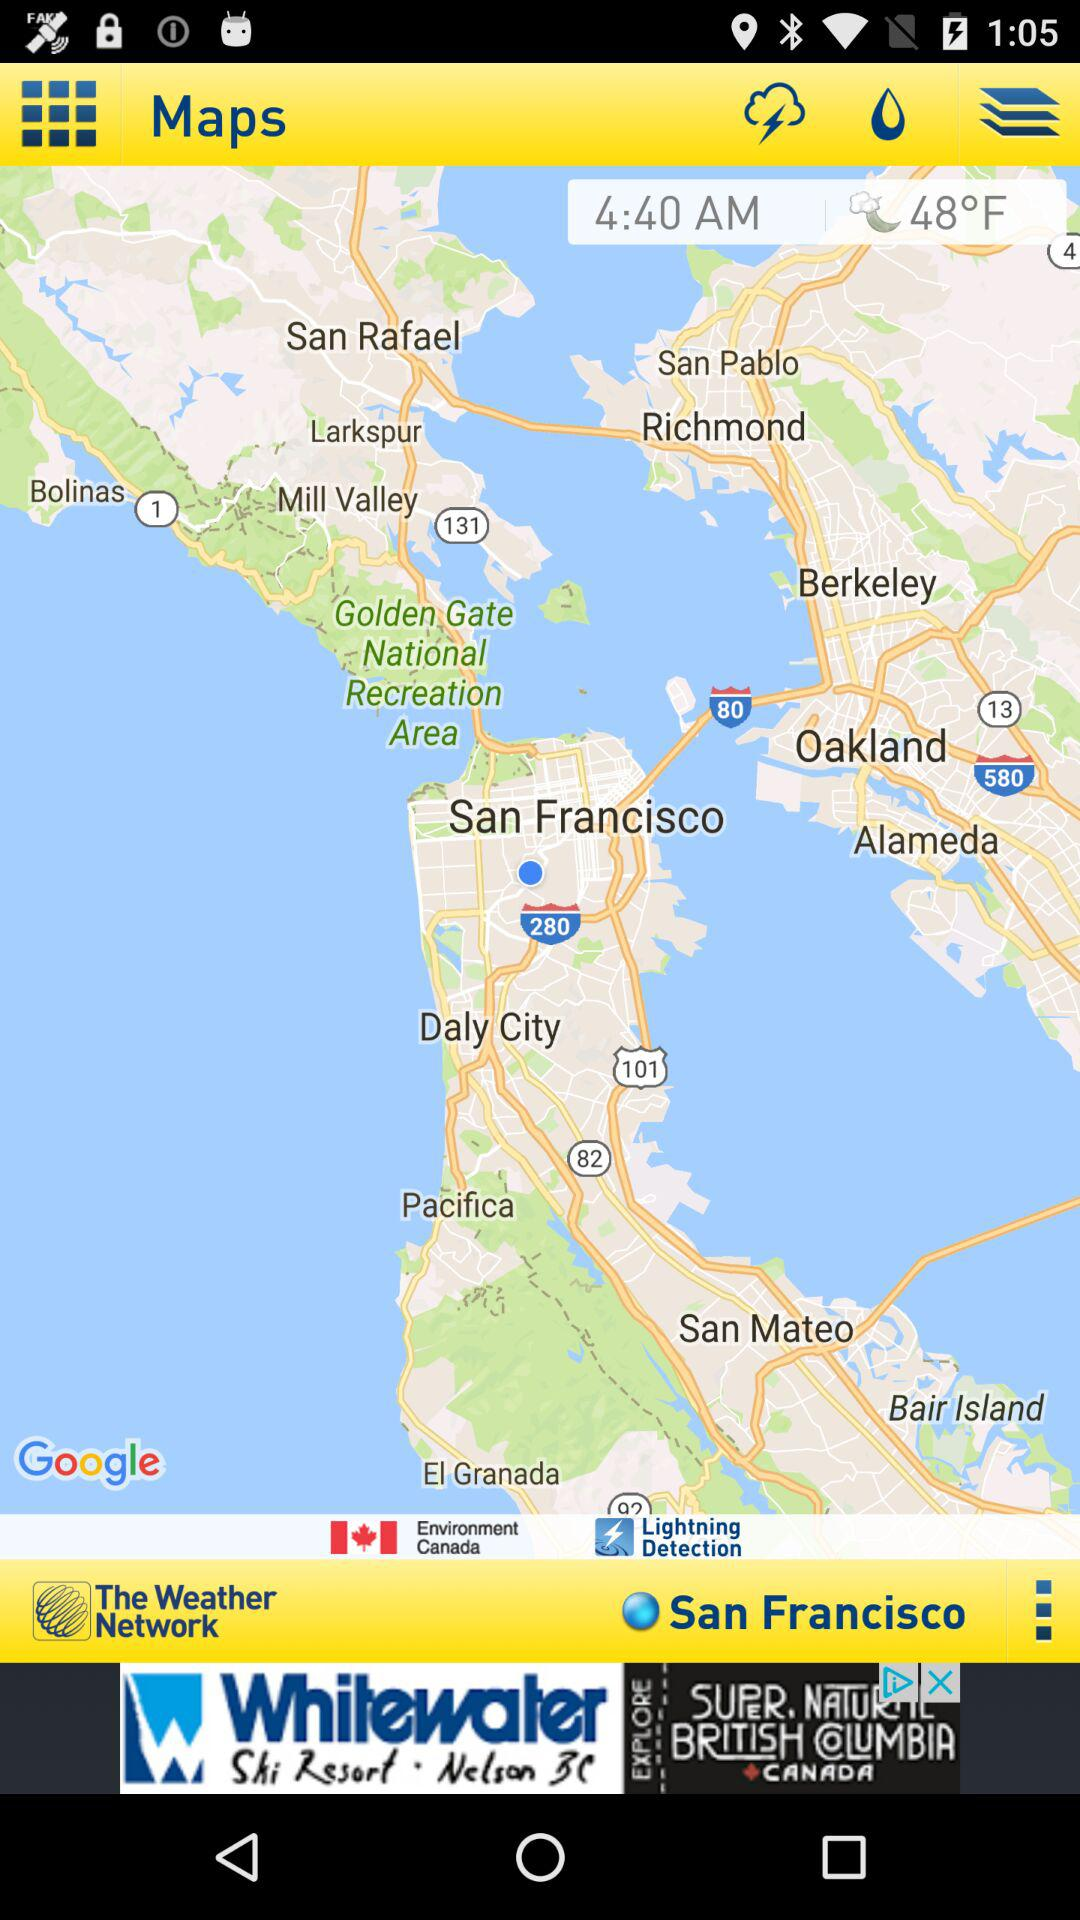Which place's time and date show?
When the provided information is insufficient, respond with <no answer>. <no answer> 